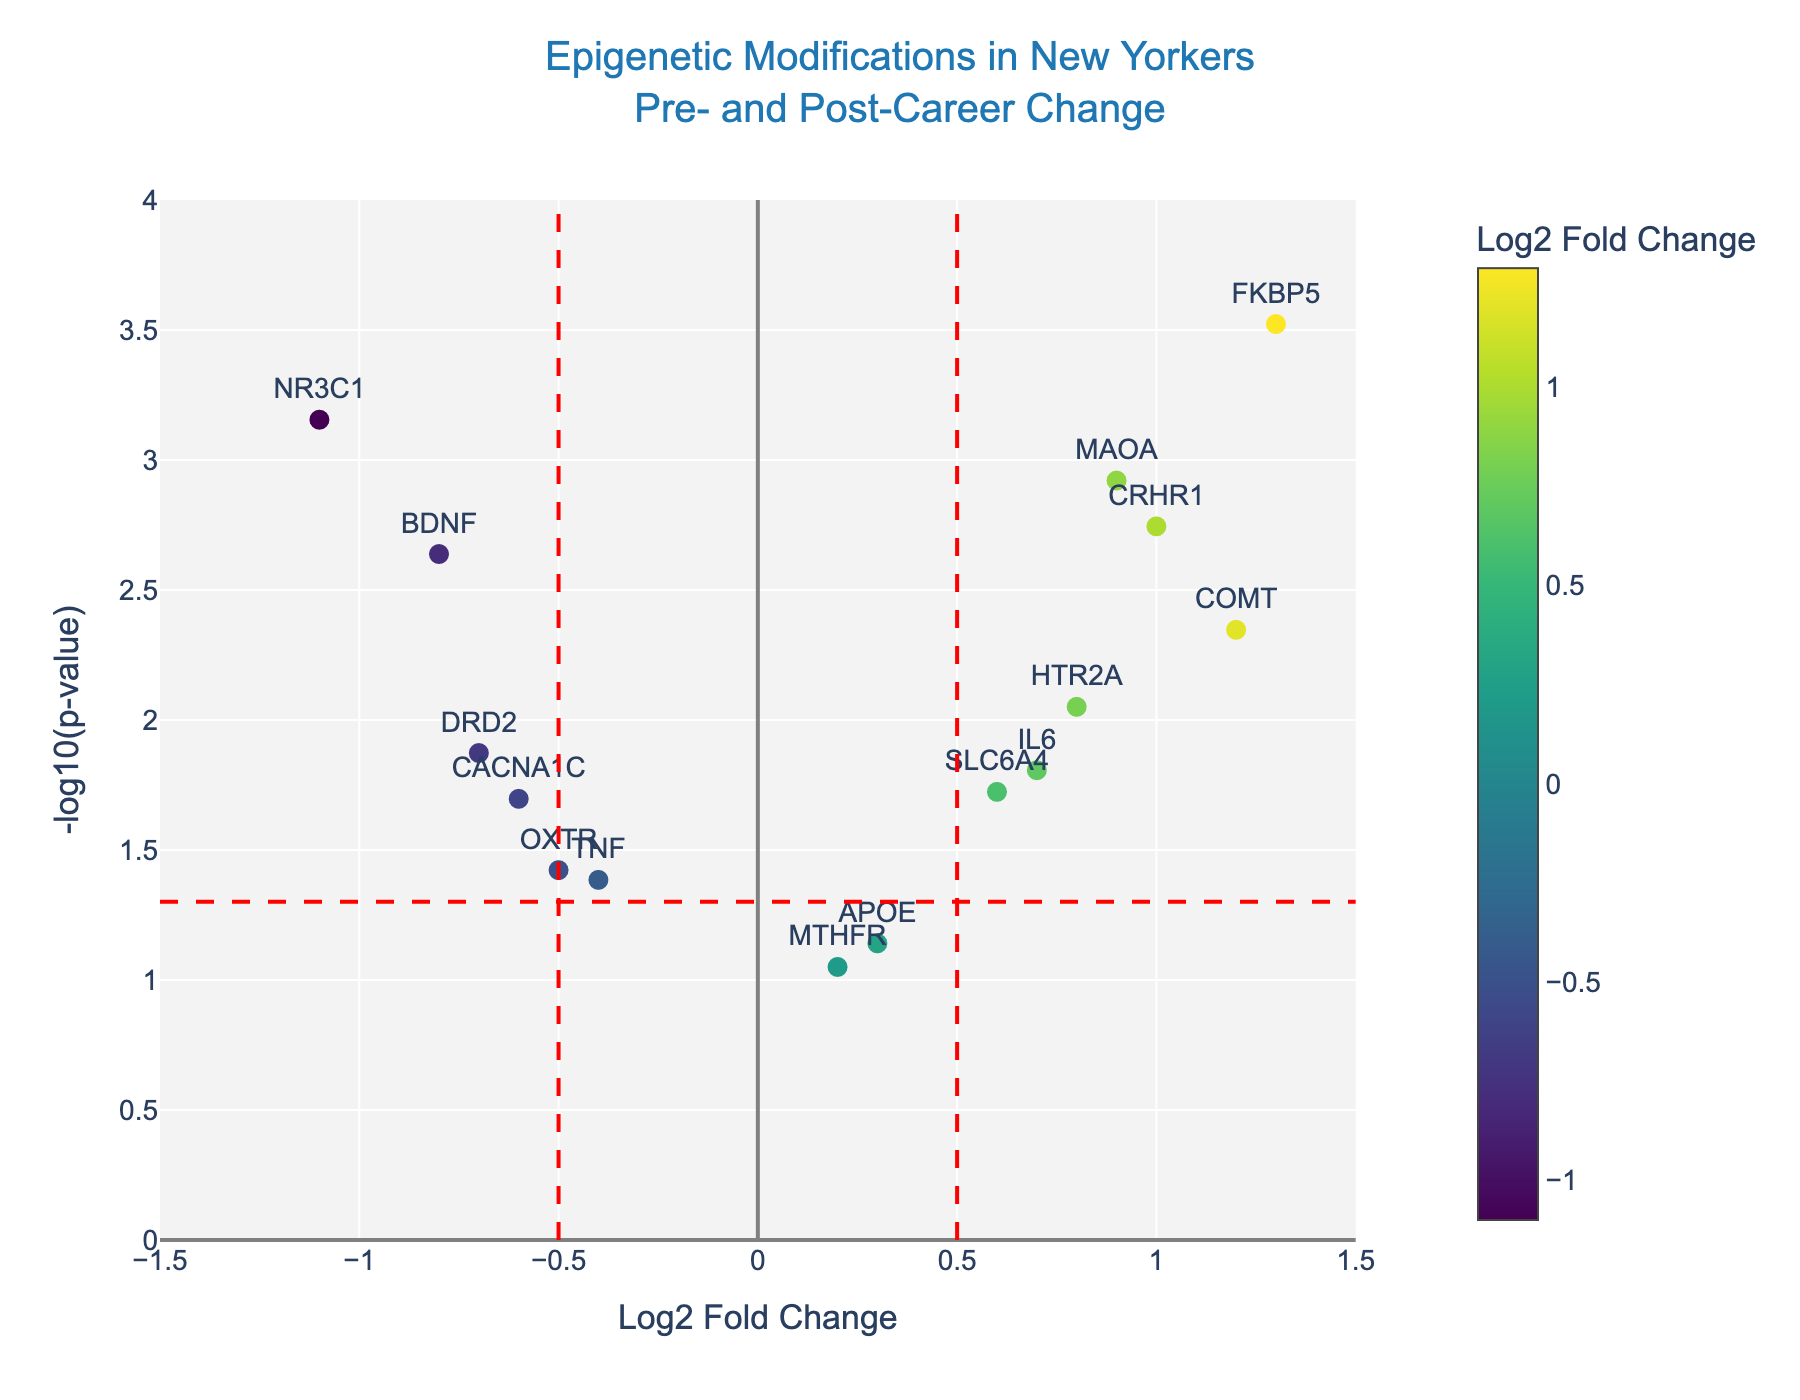What is the title of the figure? The title is displayed at the top center of the figure and reads "Epigenetic Modifications in New Yorkers Pre- and Post-Career Change."
Answer: Epigenetic Modifications in New Yorkers Pre- and Post-Career Change What does the y-axis represent? The y-axis label reads "-log10(p-value)," which indicates that the y-axis represents the negative logarithm (base 10) of the p-value for each gene.
Answer: -log10(p-value) How many genes have a log2 fold change greater than 0.5? Count the points to the right of the vertical red dashed line at x=0.5. These genes are COMT, MAOA, FKBP5, IL6, HTR2A, and CRHR1.
Answer: 6 Which gene exhibits the most statistically significant change? The most statistically significant change corresponds to the highest value on the y-axis, which represents the lowest p-value. FKBP5 shows the highest -log10(p-value).
Answer: FKBP5 What is the log2 fold change of the COMT gene? The log2 fold change of the COMT gene is indicated by the x-coordinate of the point labeled "COMT."
Answer: 1.2 How many genes fall below the p-value threshold of 0.05? Identify the points above the horizontal red dashed line at y=-log10(0.05). The genes are BDNF, COMT, SLC6A4, OXTR, MAOA, NR3C1, FKBP5, IL6, CACNA1C, HTR2A, DRD2, and CRHR1.
Answer: 12 Which gene has the lowest log2 fold change? The lowest log2 fold change corresponds to the leftmost point on the x-axis. This is the NR3C1 gene.
Answer: NR3C1 What does the color of the markers represent? The color of the markers, as shown by the color bar, represents the log2 fold change values.
Answer: Log2 fold change Which genes have a log2 fold change between -0.5 and 0.5 and are below the p-value threshold of 0.05? Identify the points between the two vertical red dashed lines (-0.5 < x < 0.5) and above the horizontal red dashed line (y > -log10(0.05)). These genes are SLC6A4, OXTR, TNF, APOE, and DRD2.
Answer: SLC6A4, OXTR, TNF, APOE, DRD2 